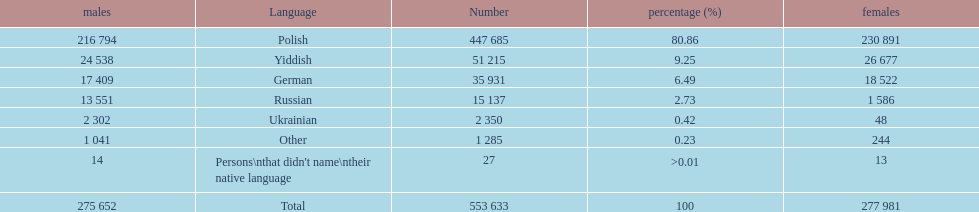How many speakers (of any language) are represented on the table ? 553 633. 